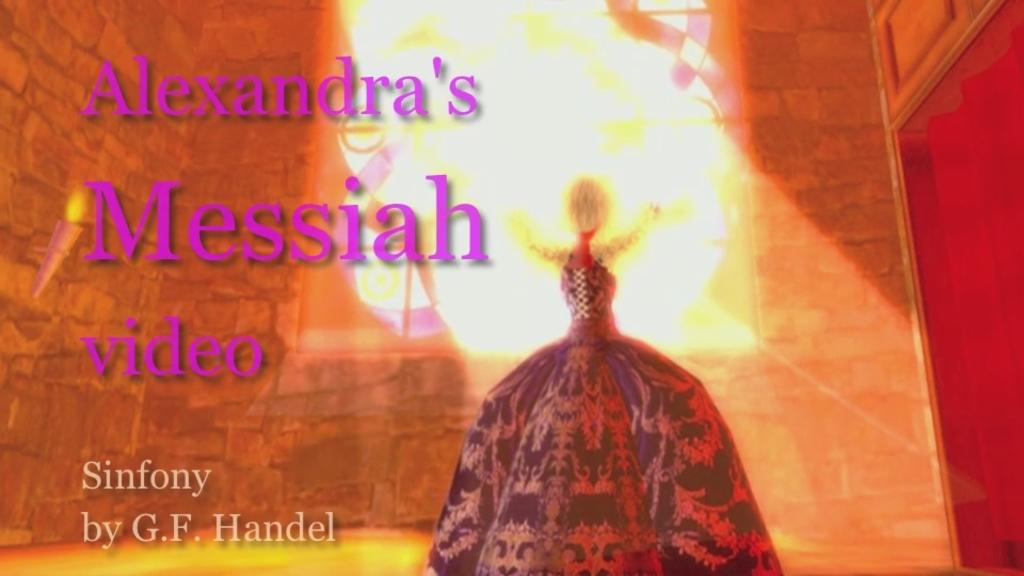<image>
Create a compact narrative representing the image presented. the name sinfony that is next to a person 